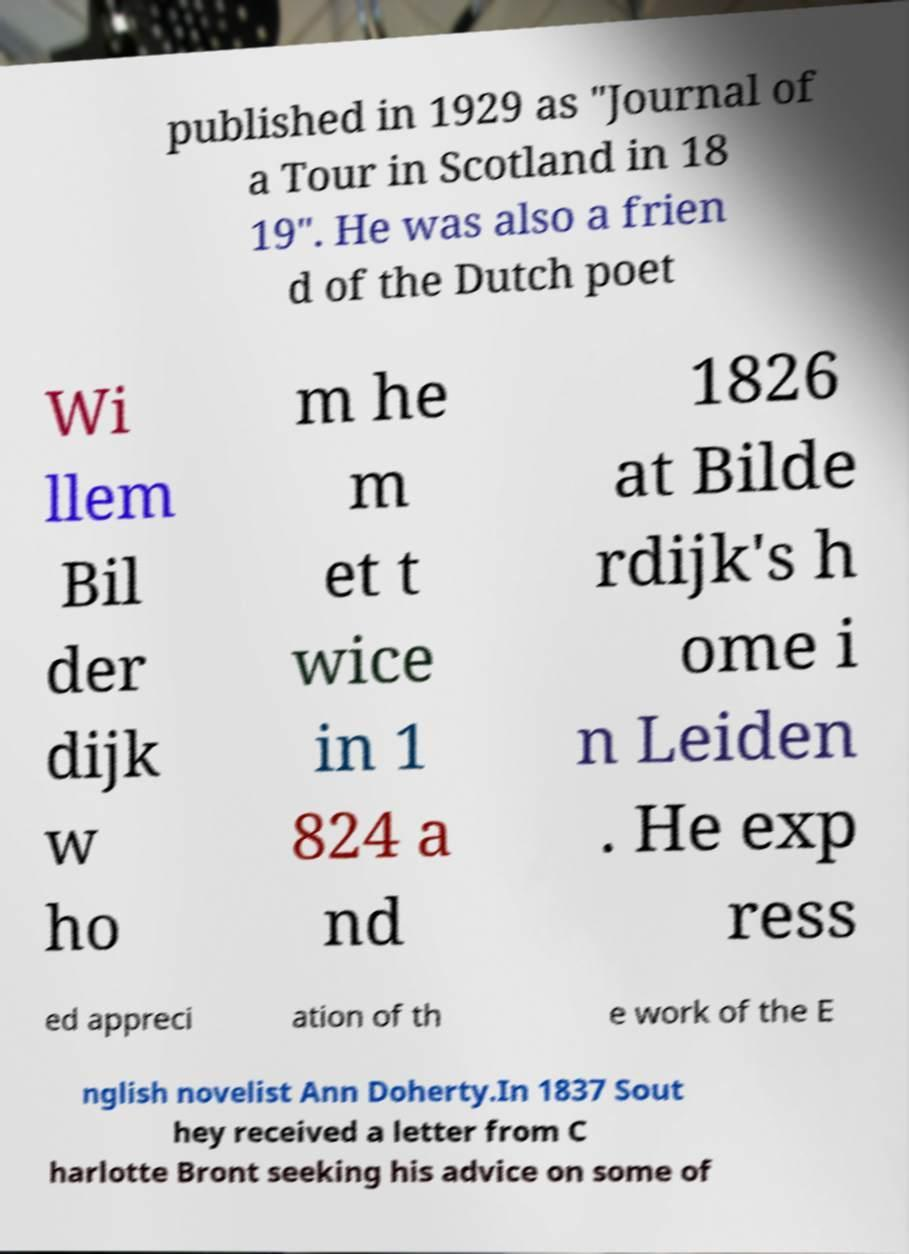Could you extract and type out the text from this image? published in 1929 as "Journal of a Tour in Scotland in 18 19". He was also a frien d of the Dutch poet Wi llem Bil der dijk w ho m he m et t wice in 1 824 a nd 1826 at Bilde rdijk's h ome i n Leiden . He exp ress ed appreci ation of th e work of the E nglish novelist Ann Doherty.In 1837 Sout hey received a letter from C harlotte Bront seeking his advice on some of 